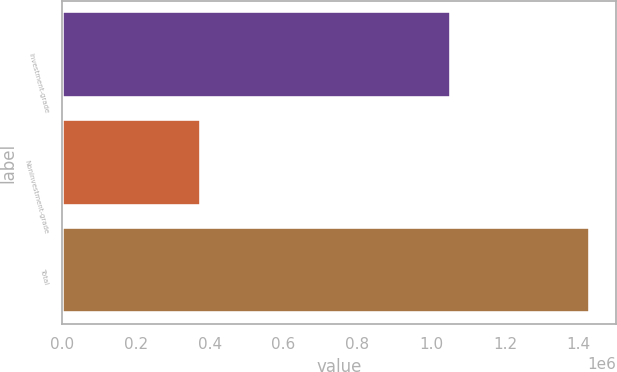<chart> <loc_0><loc_0><loc_500><loc_500><bar_chart><fcel>Investment-grade<fcel>Noninvestment-grade<fcel>Total<nl><fcel>1.05341e+06<fcel>375431<fcel>1.42884e+06<nl></chart> 